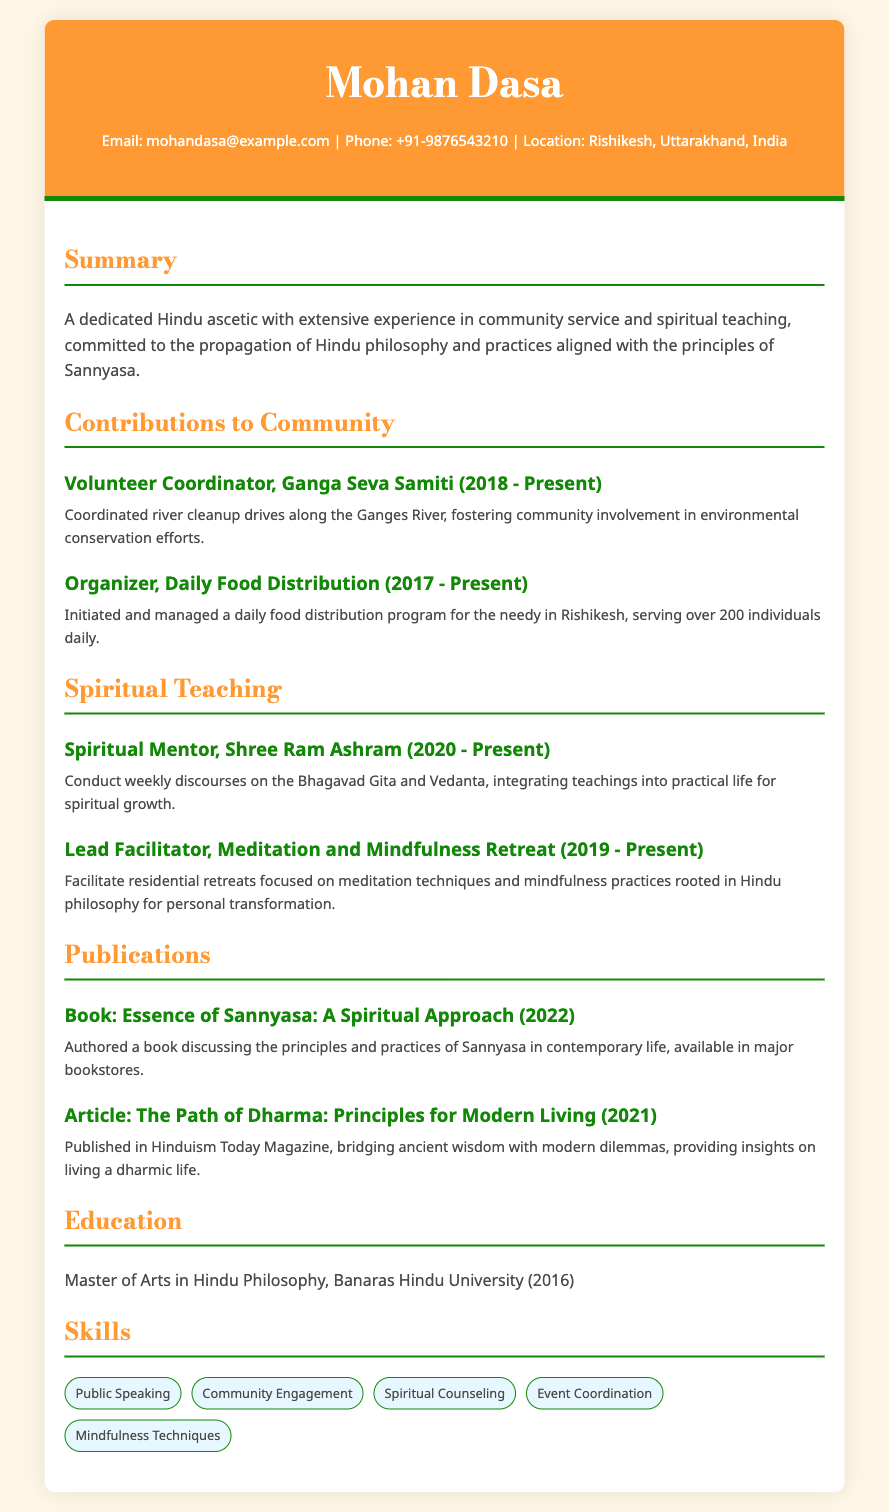What is the name of the volunteer organization? The document mentions Ganga Seva Samiti as the volunteer organization.
Answer: Ganga Seva Samiti When did Mohan Dasa start coordinating river cleanup drives? The document states that he has been a Volunteer Coordinator since 2018.
Answer: 2018 How many individuals are served daily in the food distribution program? The document indicates that over 200 individuals are served daily.
Answer: over 200 What position does Mohan Dasa hold at Shree Ram Ashram? The document refers to him as a Spiritual Mentor at Shree Ram Ashram.
Answer: Spiritual Mentor What is the title of the book authored by Mohan Dasa? The document states that his book is titled "Essence of Sannyasa: A Spiritual Approach."
Answer: Essence of Sannyasa: A Spiritual Approach What is the highest degree earned by Mohan Dasa? The document specifies that he earned a Master of Arts in Hindu Philosophy.
Answer: Master of Arts in Hindu Philosophy Which meditation practice does Mohan Dasa facilitate retreats on? The document mentions that he facilitates retreats focused on meditation techniques and mindfulness practices.
Answer: meditation techniques and mindfulness practices In which publication was the article "The Path of Dharma" published? The document indicates that the article was published in Hinduism Today Magazine.
Answer: Hinduism Today Magazine What are the skills listed in Mohan Dasa’s CV? The skills listed include Public Speaking, Community Engagement, Spiritual Counseling, Event Coordination, and Mindfulness Techniques.
Answer: Public Speaking, Community Engagement, Spiritual Counseling, Event Coordination, Mindfulness Techniques 